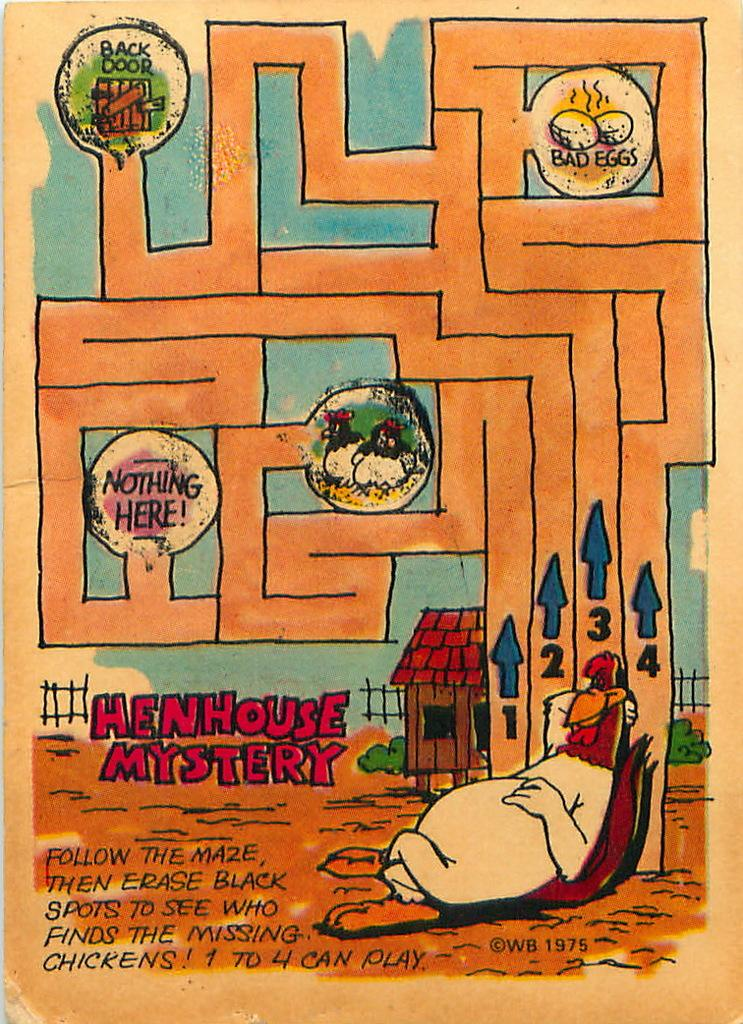<image>
Write a terse but informative summary of the picture. A Henhouse Mystery maze leads to a back door. 